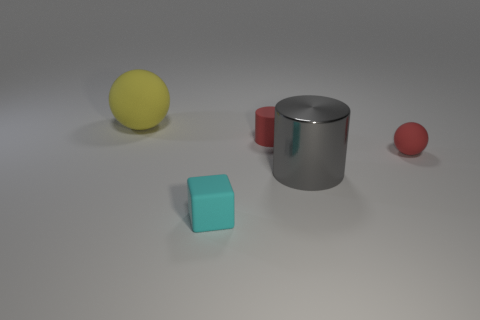Subtract 1 blocks. How many blocks are left? 0 Subtract all cylinders. How many objects are left? 3 Add 5 tiny purple metallic blocks. How many objects exist? 10 Subtract 0 gray balls. How many objects are left? 5 Subtract all red spheres. Subtract all cyan cylinders. How many spheres are left? 1 Subtract all gray cylinders. How many blue spheres are left? 0 Subtract all rubber cubes. Subtract all big cylinders. How many objects are left? 3 Add 5 small rubber balls. How many small rubber balls are left? 6 Add 5 small spheres. How many small spheres exist? 6 